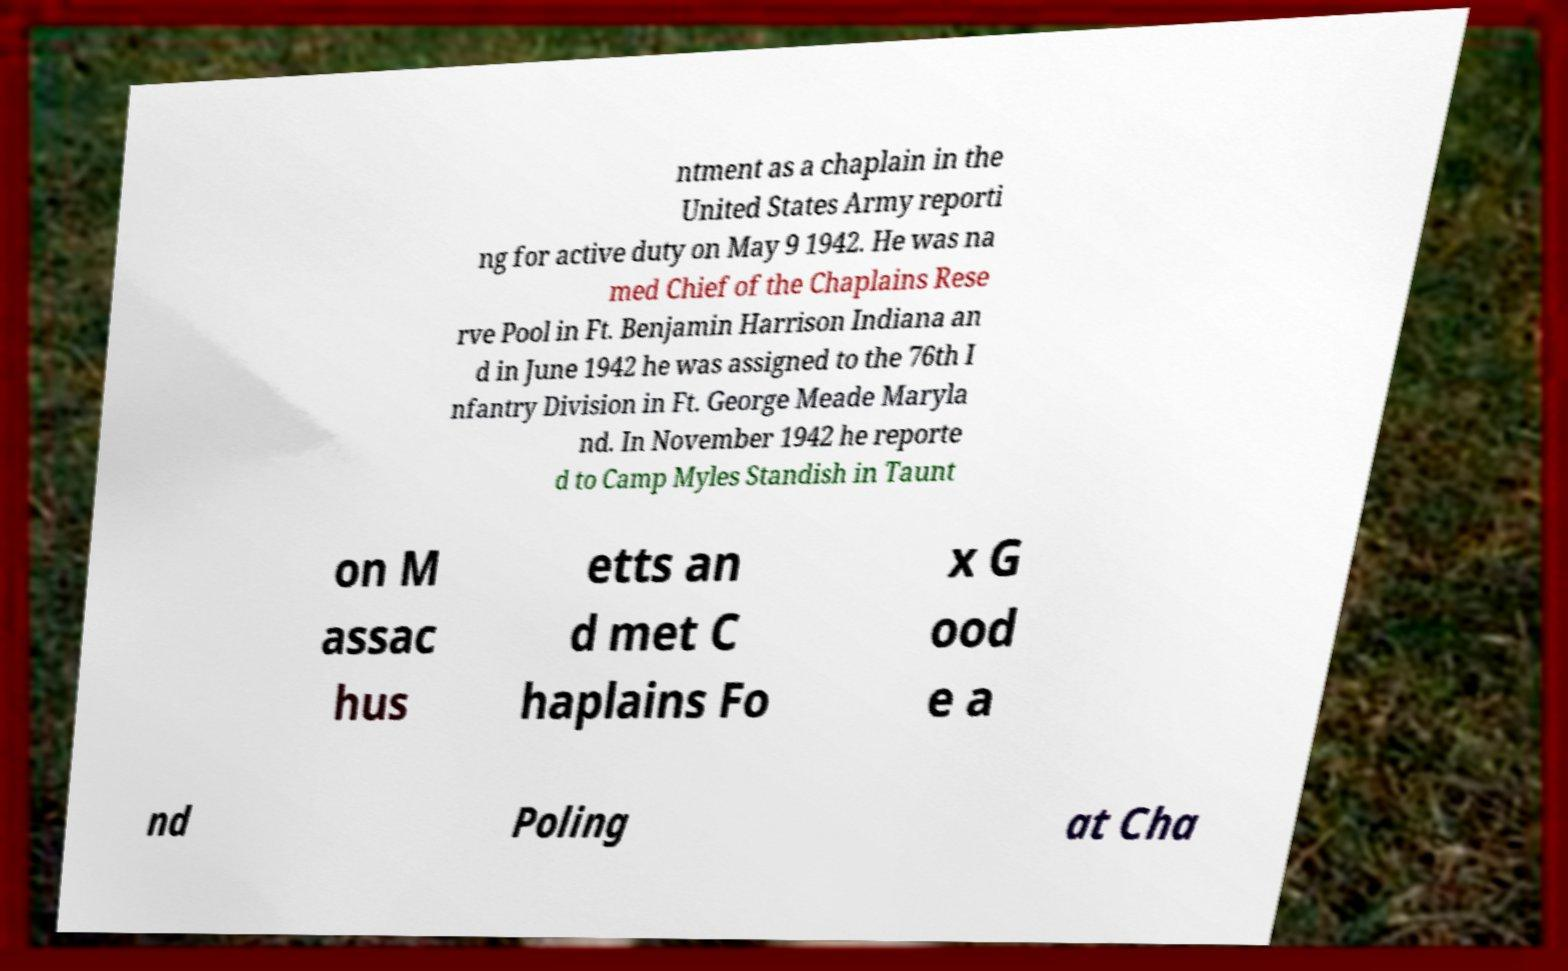Can you read and provide the text displayed in the image?This photo seems to have some interesting text. Can you extract and type it out for me? ntment as a chaplain in the United States Army reporti ng for active duty on May 9 1942. He was na med Chief of the Chaplains Rese rve Pool in Ft. Benjamin Harrison Indiana an d in June 1942 he was assigned to the 76th I nfantry Division in Ft. George Meade Maryla nd. In November 1942 he reporte d to Camp Myles Standish in Taunt on M assac hus etts an d met C haplains Fo x G ood e a nd Poling at Cha 